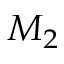Convert formula to latex. <formula><loc_0><loc_0><loc_500><loc_500>M _ { 2 }</formula> 